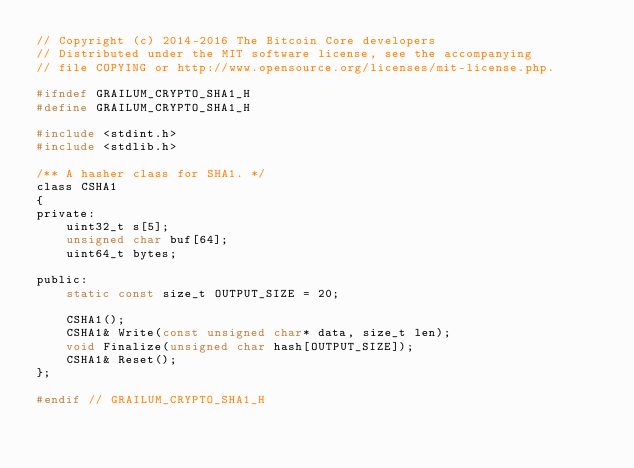<code> <loc_0><loc_0><loc_500><loc_500><_C_>// Copyright (c) 2014-2016 The Bitcoin Core developers
// Distributed under the MIT software license, see the accompanying
// file COPYING or http://www.opensource.org/licenses/mit-license.php.

#ifndef GRAILUM_CRYPTO_SHA1_H
#define GRAILUM_CRYPTO_SHA1_H

#include <stdint.h>
#include <stdlib.h>

/** A hasher class for SHA1. */
class CSHA1
{
private:
    uint32_t s[5];
    unsigned char buf[64];
    uint64_t bytes;

public:
    static const size_t OUTPUT_SIZE = 20;

    CSHA1();
    CSHA1& Write(const unsigned char* data, size_t len);
    void Finalize(unsigned char hash[OUTPUT_SIZE]);
    CSHA1& Reset();
};

#endif // GRAILUM_CRYPTO_SHA1_H
</code> 